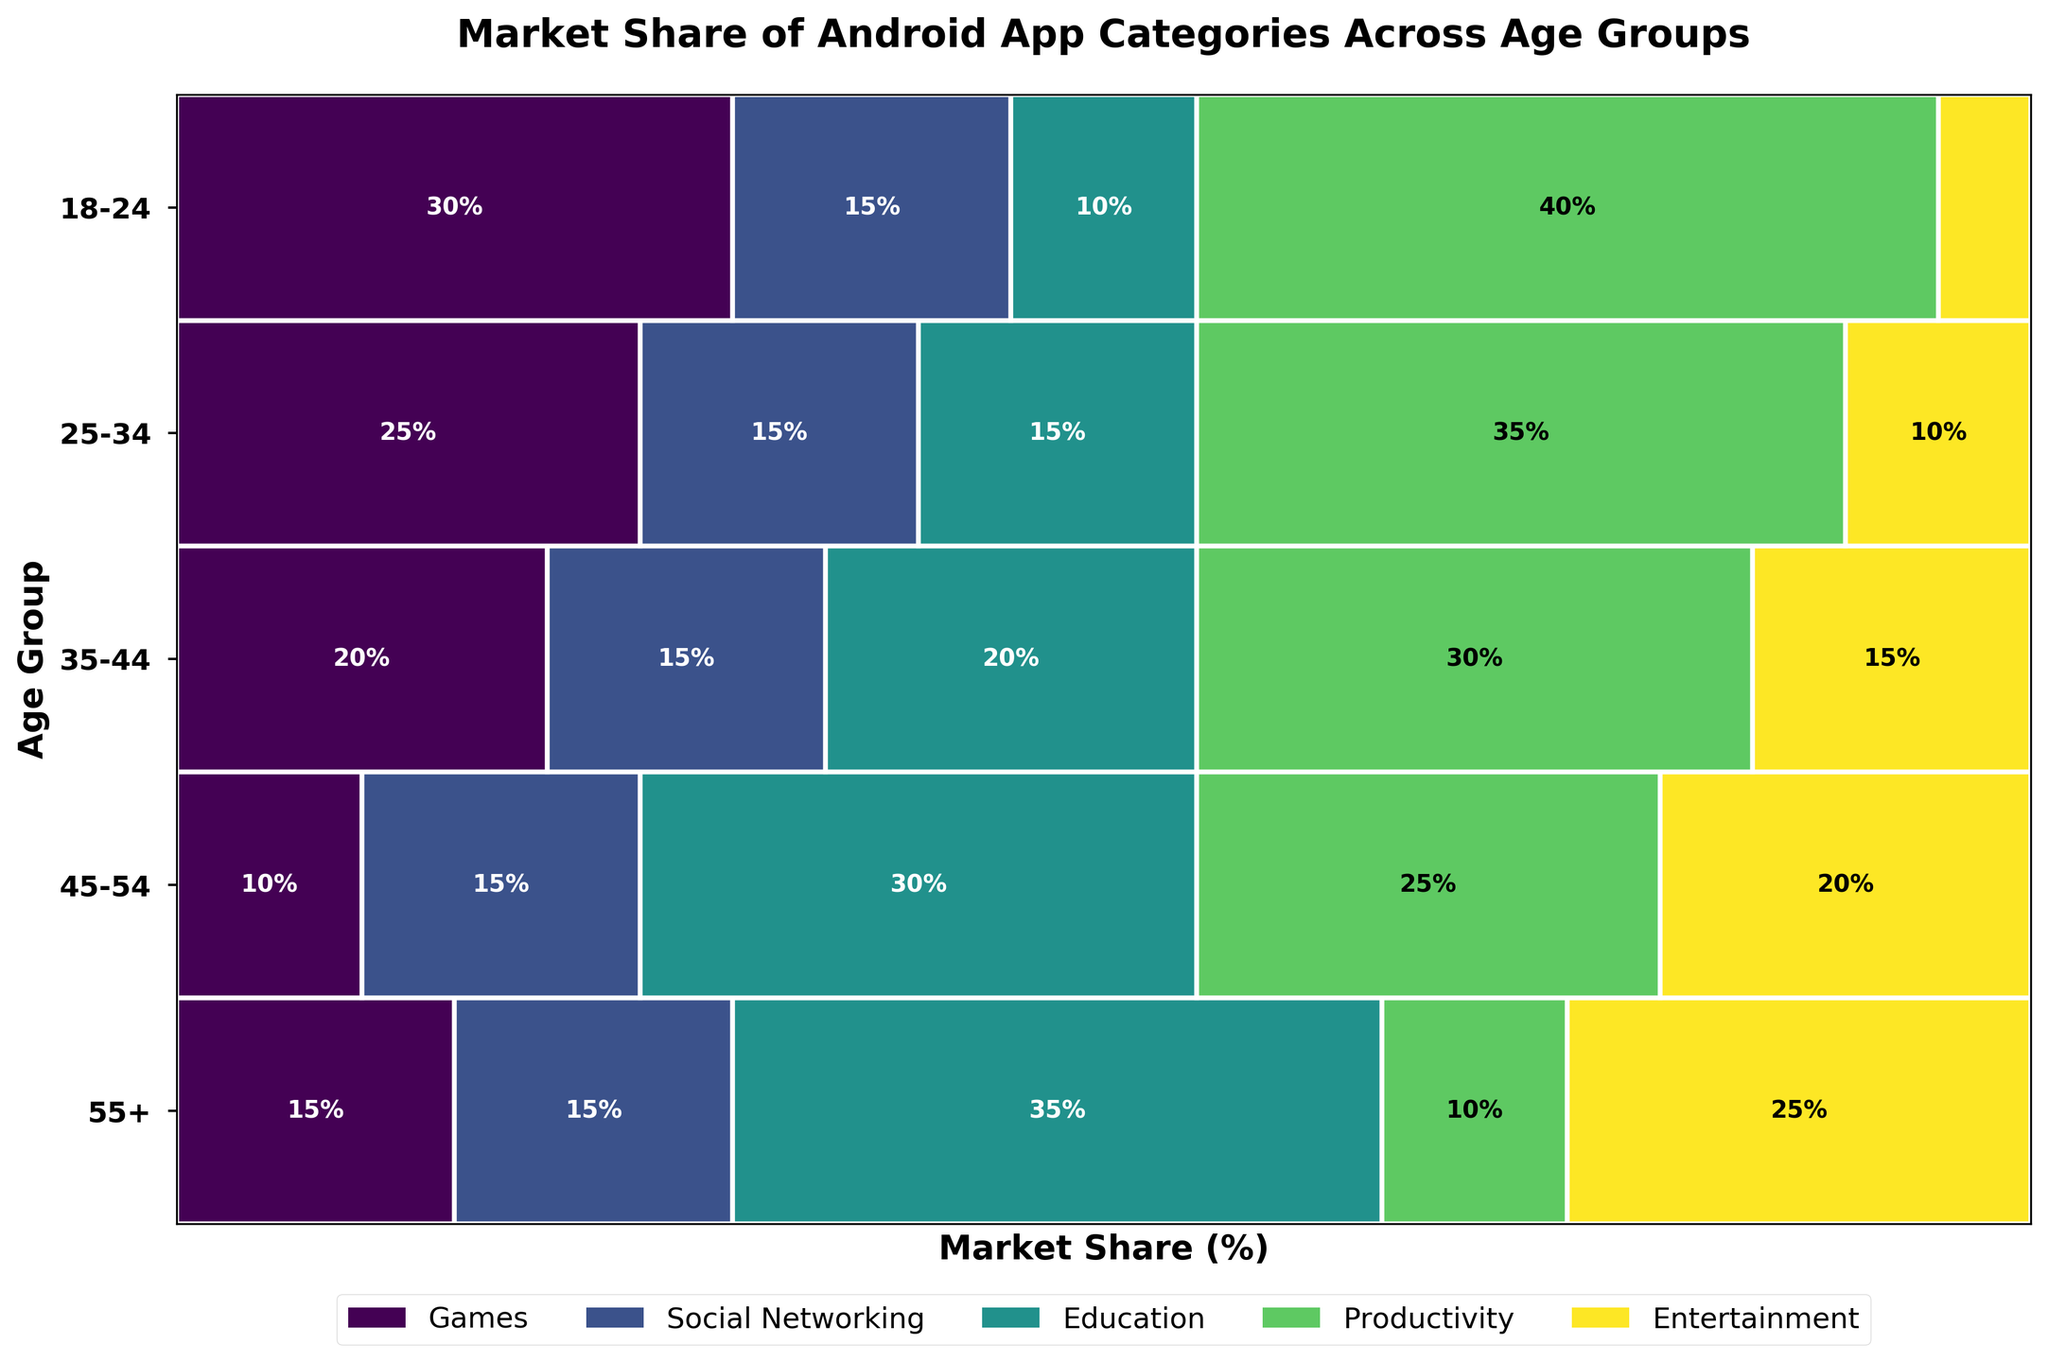What is the title of the plot? The title of the plot is usually displayed at the top center of the graph. For this particular plot, it should summarize what the data is representing.
Answer: Market Share of Android App Categories Across Age Groups What are the age groups presented on the y-axis? The age groups are the labels on the y-axis. By reading them from top to bottom, we can identify all the age groups included in the plot.
Answer: 18-24, 25-34, 35-44, 45-54, 55+ Which app category has the largest market share for the 25-34 age group? For the 25-34 age group, we need to identify the widest rectangle and check the label within or adjacent to the rectangle. This represents the largest market share.
Answer: Productivity Compare the market share of the Games category between the 18-24 and 45-54 age groups. Which group has a higher share? We compare the width of the rectangles for the Games category between the two age groups. The wider the rectangle, the higher the market share.
Answer: 18-24 How does the market share of Education apps change across different age groups? Observe the rectangles corresponding to the Education category across all age groups. By examining the widths of each age group for Education, we can identify the trend or change.
Answer: Increases with age What is the total market share of Entertainment apps across all age groups? Sum the widths of the rectangles for the Entertainment category in each age group to find the total market share across all age groups.
Answer: 75% Which age group has the smallest market share for the Social Networking category? Look for the narrowest (or smallest) rectangle representing the Social Networking category and note the age group it belongs to.
Answer: 55+ Calculate the difference in market share for Productivity apps between the 25-34 and 55+ age groups. Identify the widths of the rectangles for Productivity in both age groups and subtract the market share of the 25-34 group from that of the 55+ group.
Answer: 15% Among all the age groups, which app category consistently appears to have a market share between 10% and 15%? Check each age group to find an app category where the width of their rectangles remains within the 10%-15% range. This category should be consistent across all age groups.
Answer: Entertainment 